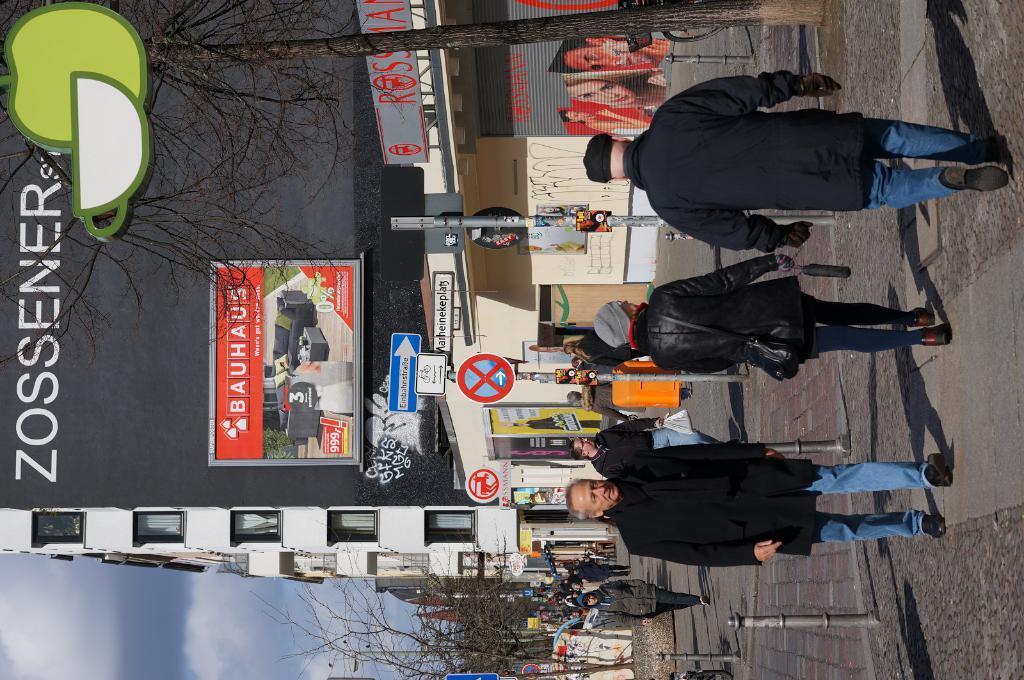Could you give a brief overview of what you see in this image? Bottom right side of the image few people are walking. Behind them there is fencing. Bottom left side of the image there are some trees. Behind the trees there are some clouds and sky. In the middle of the image there are some poles and sign boards. Top left side of the image there are some trees. Behind the trees there are some banners. Behind the banners there are some buildings. 